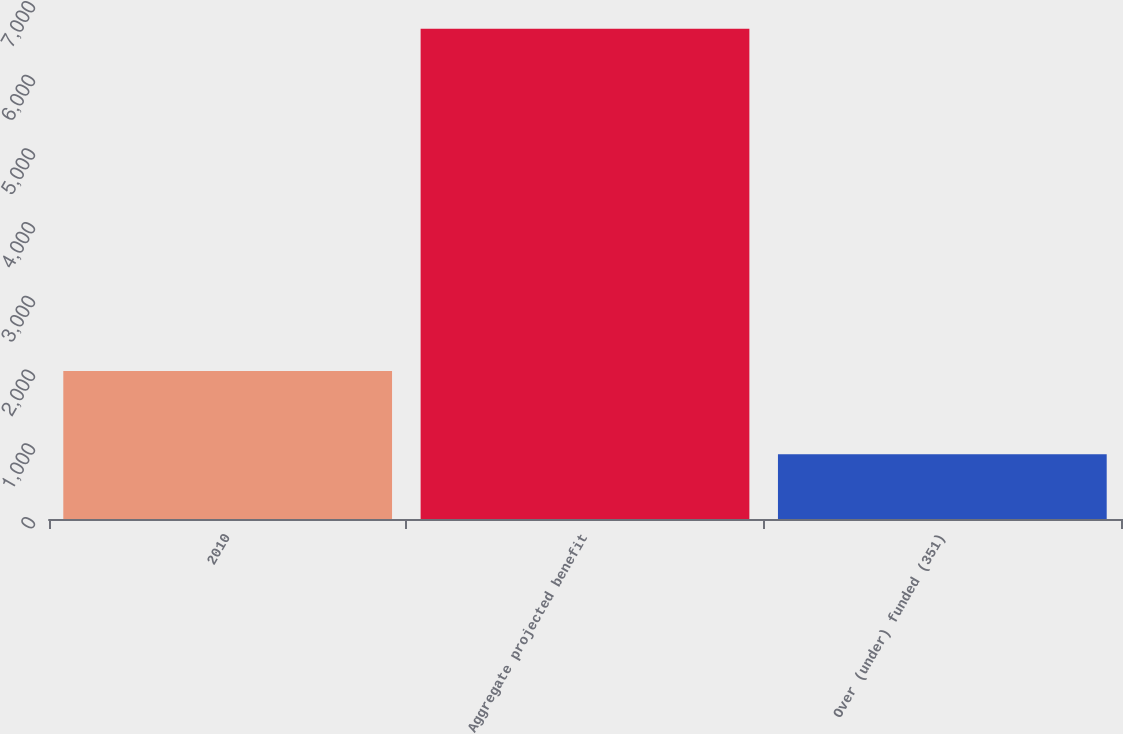Convert chart to OTSL. <chart><loc_0><loc_0><loc_500><loc_500><bar_chart><fcel>2010<fcel>Aggregate projected benefit<fcel>Over (under) funded (351)<nl><fcel>2009<fcel>6649<fcel>879<nl></chart> 